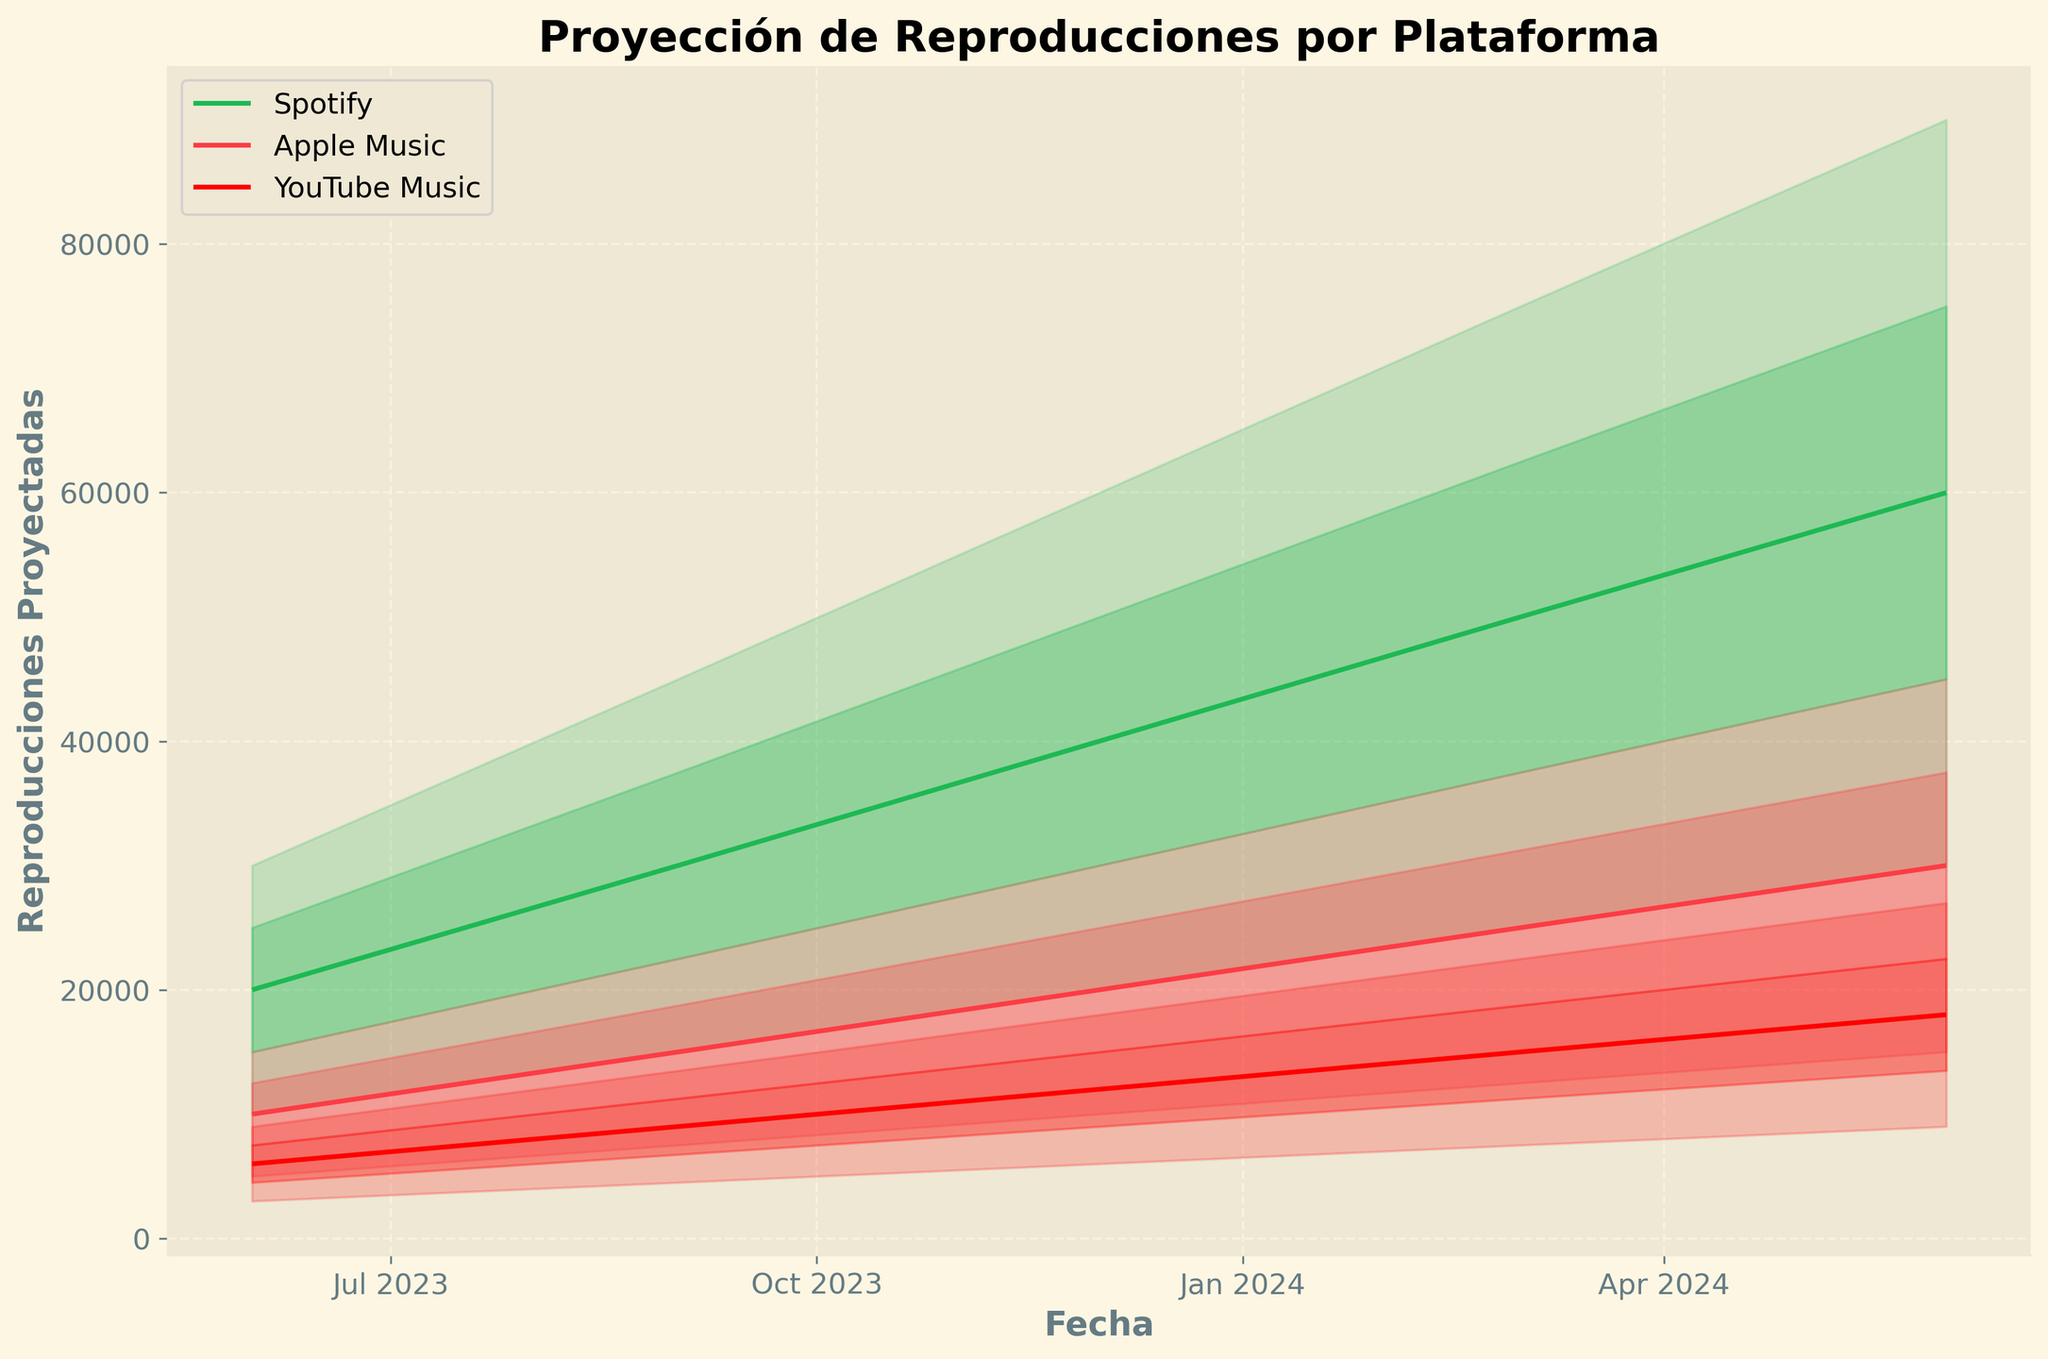¿Cuál es el título del gráfico? El título del gráfico está en la parte superior, claramente escrito en un tamaño de fuente más grande y en negrita.
Answer: "Proyección de Reproducciones por Plataforma" ¿Qué representa el eje X y el eje Y del gráfico? El eje X está etiquetado como "Fecha", mientras que el eje Y está etiquetado como "Reproducciones Proyectadas", indicando que el gráfico muestra las proyecciones de streams a lo largo del tiempo.
Answer: Fecha y Reproducciones Proyectadas ¿Cómo se diferencian visualmente las plataformas en el gráfico? Las plataformas se diferencian por diferentes colores y estilos de línea. Spotify en verde, Apple Music en rojo claro, y YouTube Music en rojo más oscuro.
Answer: Colores y estilos de línea diferentes ¿Cuál es la proyección mediana de streams en Spotify para junio de 2024? La mediana (P50) para Spotify en junio de 2024 se encuentra en el punto medio de la línea verde que corresponde a los datos de junio de 2024. Esta línea generalmente está en el centro de las bandas sombreadas.
Answer: 60,000 ¿Cuántos meses hay entre el primer y último punto del eje X? Contamos el número de meses desde junio de 2023 hasta junio de 2024.
Answer: 12 meses 